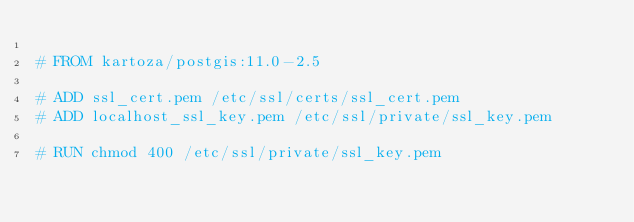<code> <loc_0><loc_0><loc_500><loc_500><_Dockerfile_>
# FROM kartoza/postgis:11.0-2.5

# ADD ssl_cert.pem /etc/ssl/certs/ssl_cert.pem
# ADD localhost_ssl_key.pem /etc/ssl/private/ssl_key.pem

# RUN chmod 400 /etc/ssl/private/ssl_key.pem</code> 